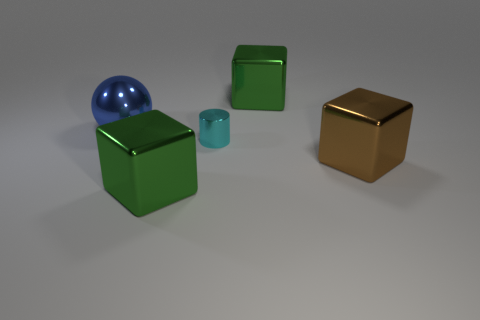Add 2 large brown blocks. How many objects exist? 7 Subtract all blocks. How many objects are left? 2 Subtract all green things. Subtract all green things. How many objects are left? 1 Add 2 brown metal objects. How many brown metal objects are left? 3 Add 1 cyan metallic cylinders. How many cyan metallic cylinders exist? 2 Subtract 0 yellow balls. How many objects are left? 5 